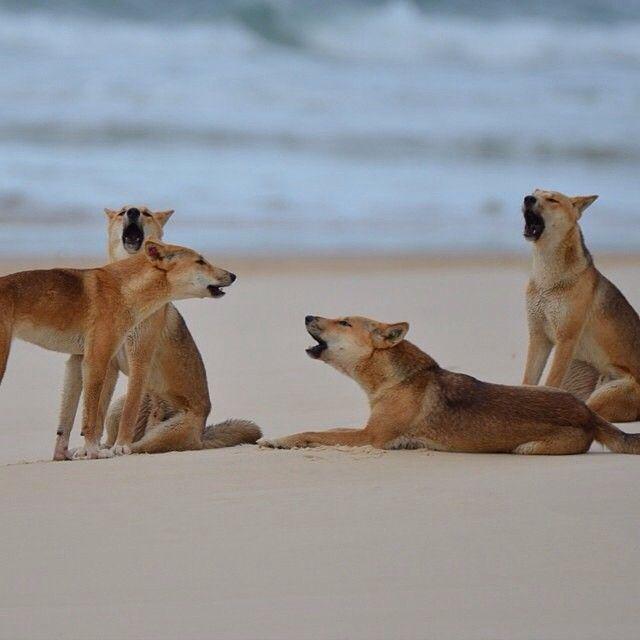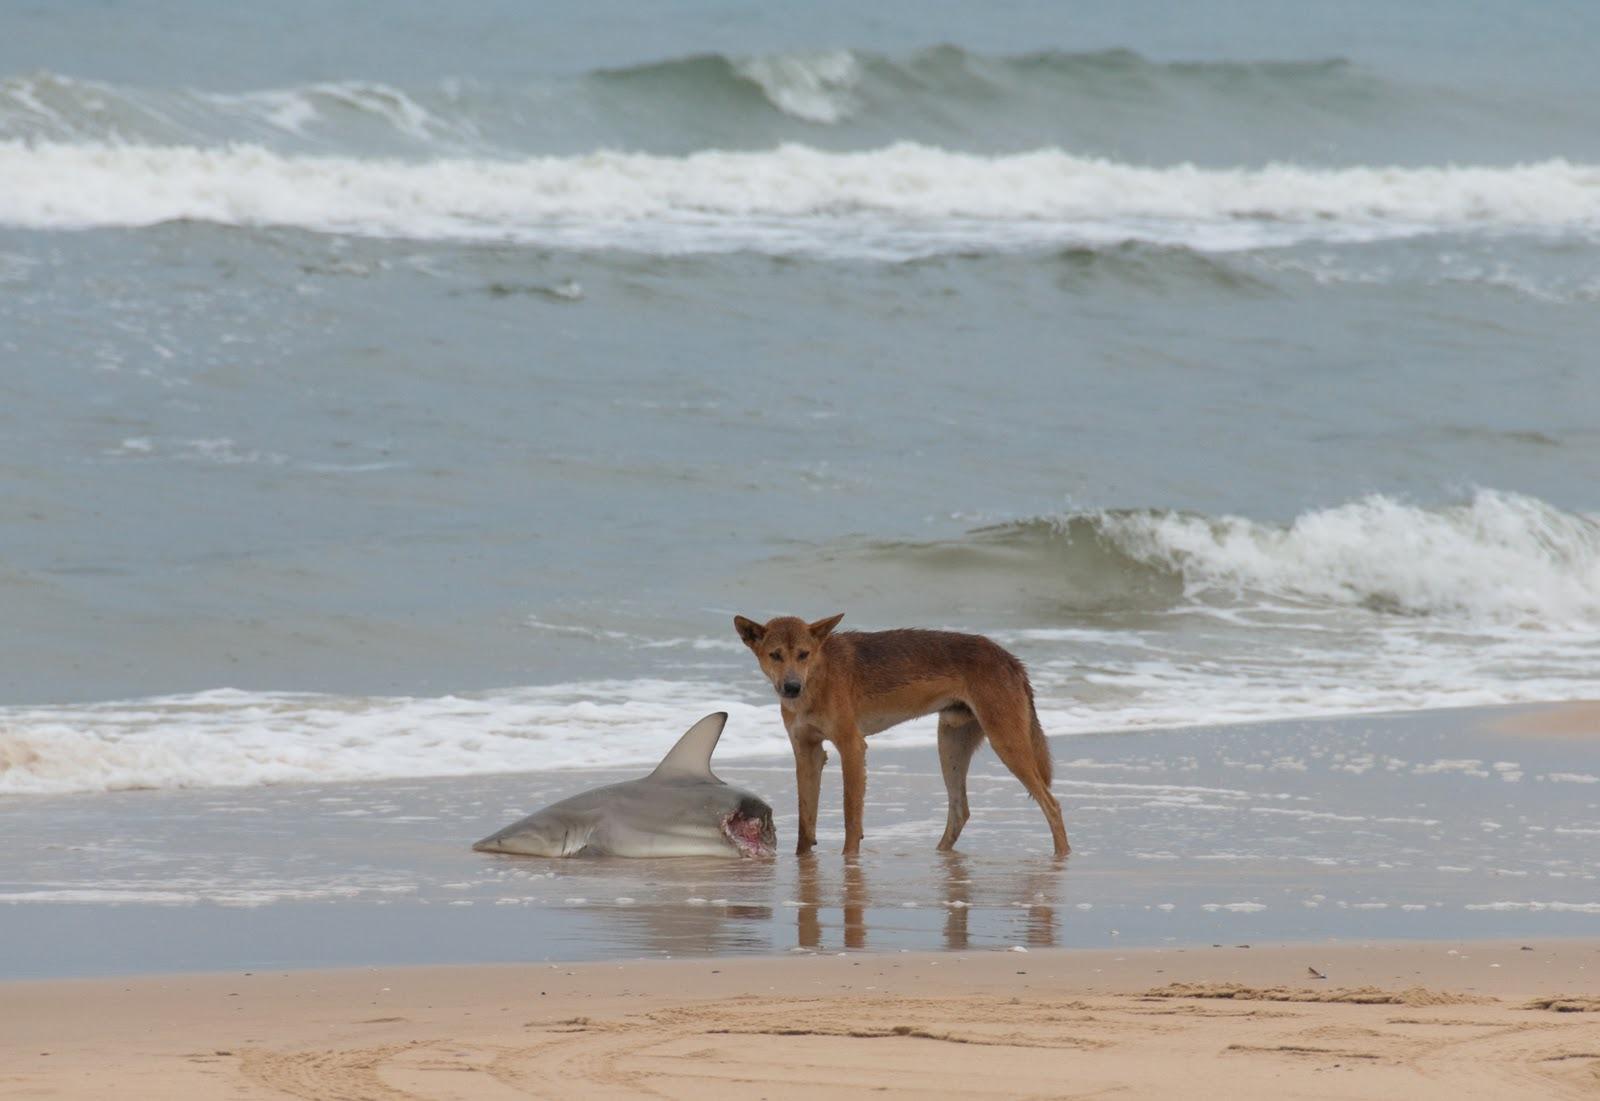The first image is the image on the left, the second image is the image on the right. Assess this claim about the two images: "The right image contains a dog on the beach next to a dead shark.". Correct or not? Answer yes or no. Yes. The first image is the image on the left, the second image is the image on the right. Assess this claim about the two images: "An image shows a person in some pose to the right of a standing orange dog.". Correct or not? Answer yes or no. No. 